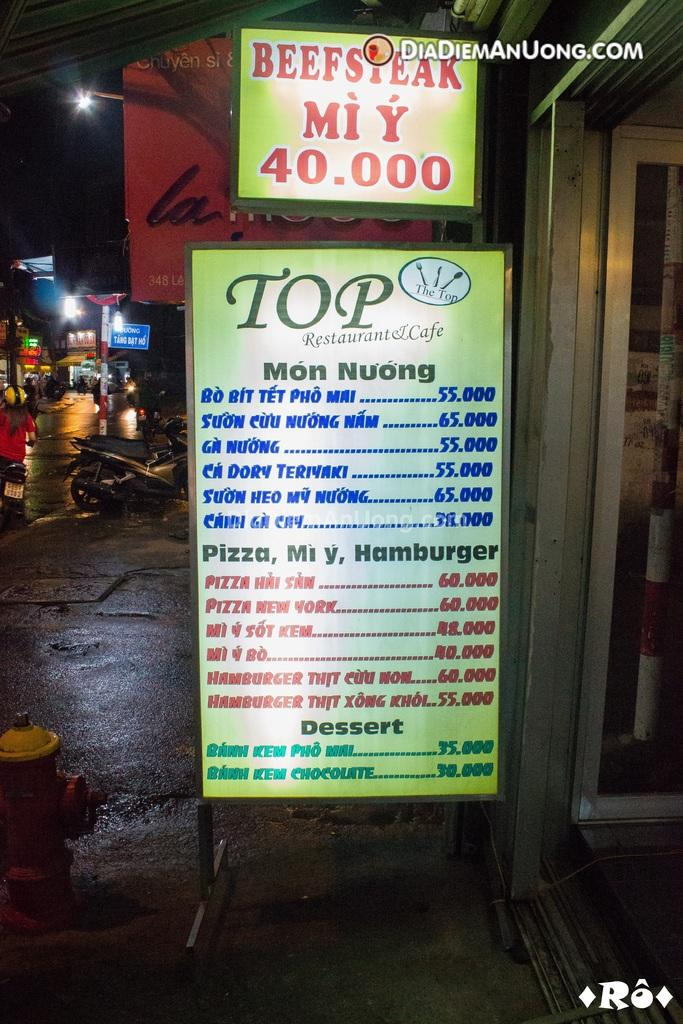What can be seen on the boards in the image? There are boards with text in the image. What type of objects are visible in the image besides the boards? There are vehicles, lights, people, poles, a hydrant, and a door in the image. Can you describe the vehicles in the image? The vehicles in the image are not specified, but they are present. What might the lights be used for in the image? The lights in the image could be used for illumination or signaling. How many times does the person in the image need to sneeze before they can open the door? There is no indication in the image that anyone needs to sneeze or that sneezing is related to opening the door. 